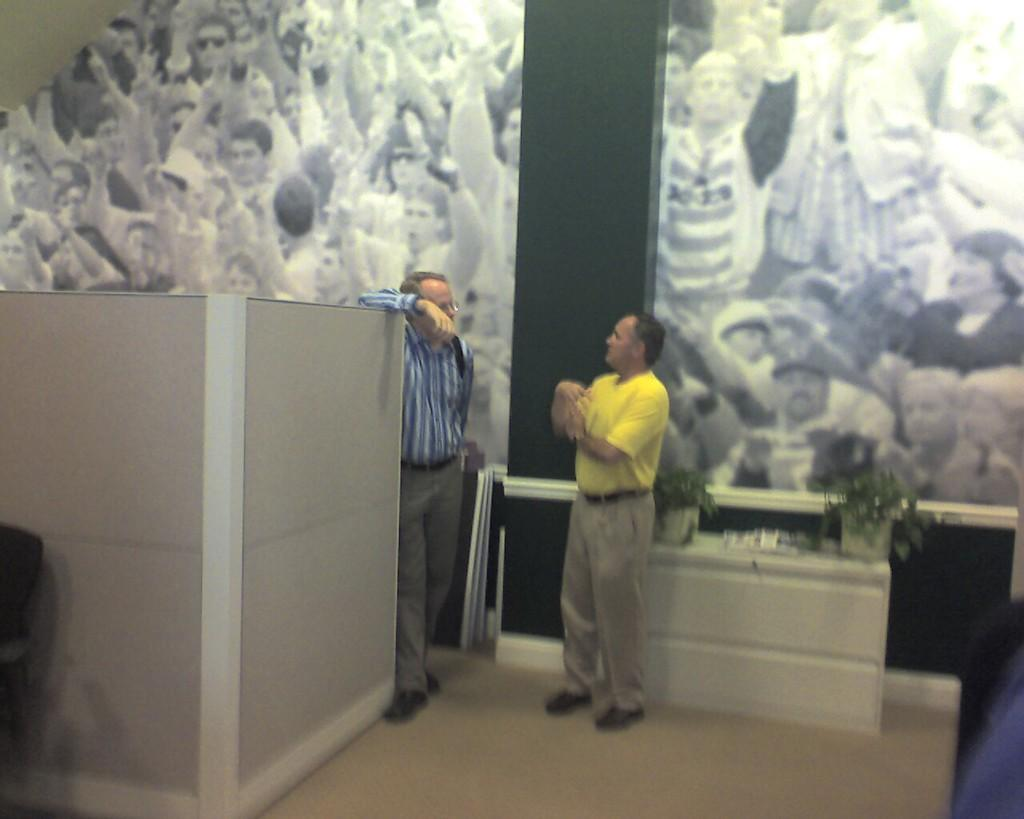How many people are in the image? There are two persons standing in the image. What can be seen on the table in the image? There are plants on the table in the image. What is the location of the other plants in the image? The plants are on a chair in the image. Can you describe any other objects in the image? There are other objects in the image, but their specific details are not mentioned in the provided facts. What is visible in the background of the image? There is a wall poster in the background of the image. How many cats are sitting on the wall poster in the image? There are no cats visible on the wall poster in the image. What type of lift is present in the image? There is no lift present in the image. 